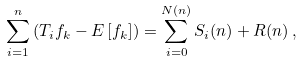<formula> <loc_0><loc_0><loc_500><loc_500>\sum _ { i = 1 } ^ { n } \left ( T _ { i } f _ { k } - { E } \left [ f _ { k } \right ] \right ) = \sum _ { i = 0 } ^ { N ( n ) } S _ { i } ( n ) + R ( n ) \, ,</formula> 